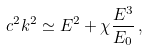Convert formula to latex. <formula><loc_0><loc_0><loc_500><loc_500>c ^ { 2 } k ^ { 2 } \simeq E ^ { 2 } + \chi \frac { E ^ { 3 } } { E _ { 0 } } \, ,</formula> 